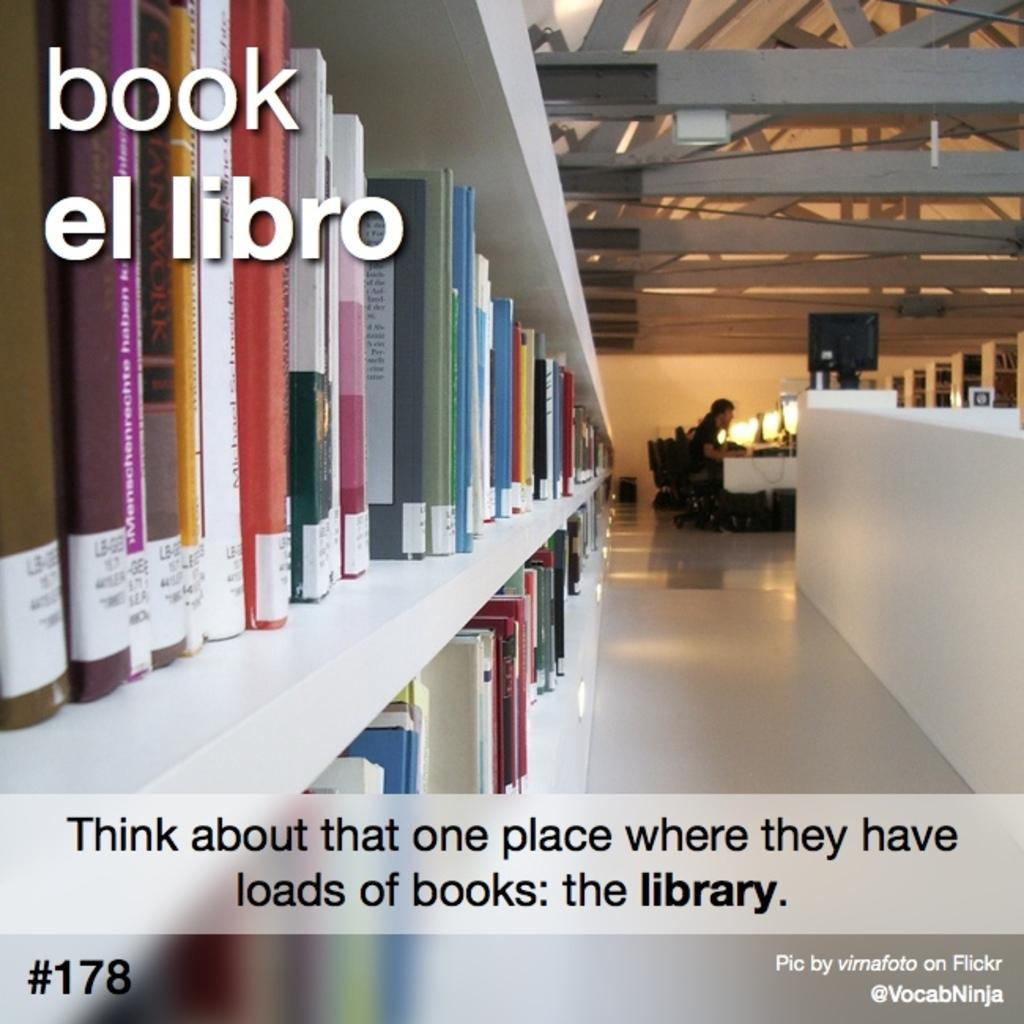<image>
Summarize the visual content of the image. A woman is seen in the distance, sitting at a desk, in a library, on a poster that has a message for more people to go to the library. 